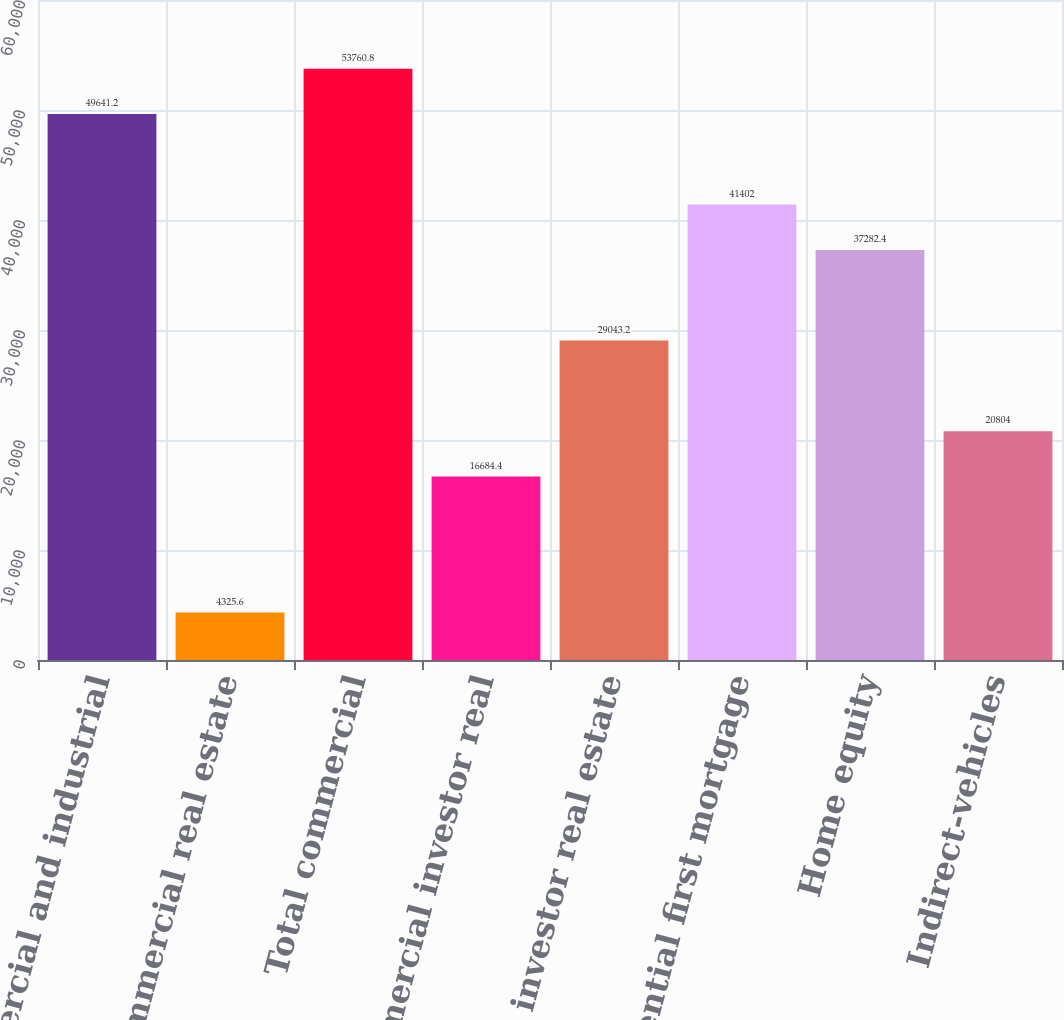<chart> <loc_0><loc_0><loc_500><loc_500><bar_chart><fcel>Commercial and industrial<fcel>Commercial real estate<fcel>Total commercial<fcel>Commercial investor real<fcel>Total investor real estate<fcel>Residential first mortgage<fcel>Home equity<fcel>Indirect-vehicles<nl><fcel>49641.2<fcel>4325.6<fcel>53760.8<fcel>16684.4<fcel>29043.2<fcel>41402<fcel>37282.4<fcel>20804<nl></chart> 